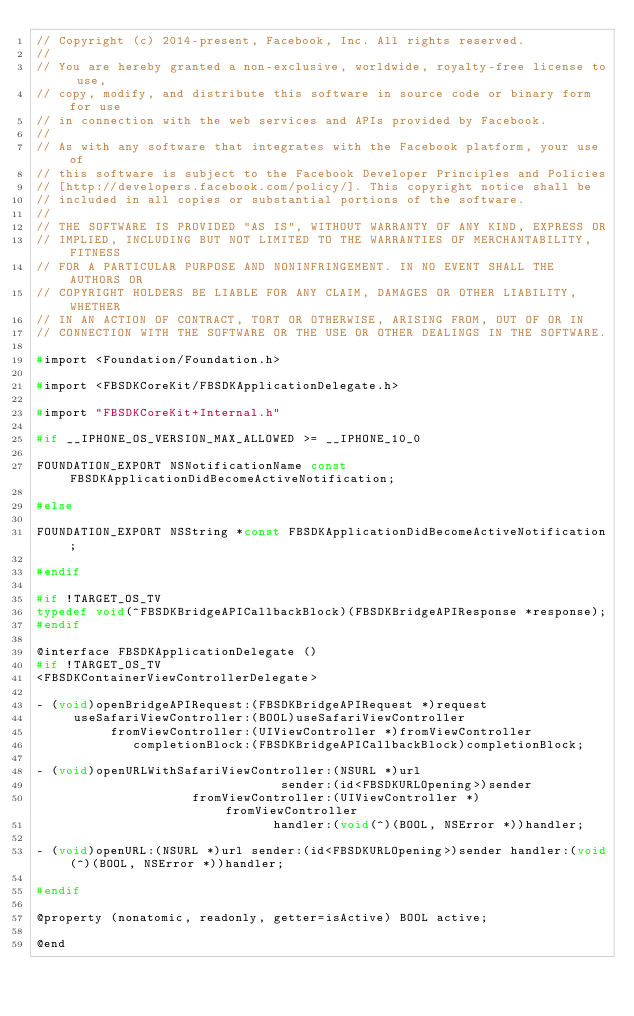Convert code to text. <code><loc_0><loc_0><loc_500><loc_500><_C_>// Copyright (c) 2014-present, Facebook, Inc. All rights reserved.
//
// You are hereby granted a non-exclusive, worldwide, royalty-free license to use,
// copy, modify, and distribute this software in source code or binary form for use
// in connection with the web services and APIs provided by Facebook.
//
// As with any software that integrates with the Facebook platform, your use of
// this software is subject to the Facebook Developer Principles and Policies
// [http://developers.facebook.com/policy/]. This copyright notice shall be
// included in all copies or substantial portions of the software.
//
// THE SOFTWARE IS PROVIDED "AS IS", WITHOUT WARRANTY OF ANY KIND, EXPRESS OR
// IMPLIED, INCLUDING BUT NOT LIMITED TO THE WARRANTIES OF MERCHANTABILITY, FITNESS
// FOR A PARTICULAR PURPOSE AND NONINFRINGEMENT. IN NO EVENT SHALL THE AUTHORS OR
// COPYRIGHT HOLDERS BE LIABLE FOR ANY CLAIM, DAMAGES OR OTHER LIABILITY, WHETHER
// IN AN ACTION OF CONTRACT, TORT OR OTHERWISE, ARISING FROM, OUT OF OR IN
// CONNECTION WITH THE SOFTWARE OR THE USE OR OTHER DEALINGS IN THE SOFTWARE.

#import <Foundation/Foundation.h>

#import <FBSDKCoreKit/FBSDKApplicationDelegate.h>

#import "FBSDKCoreKit+Internal.h"

#if __IPHONE_OS_VERSION_MAX_ALLOWED >= __IPHONE_10_0

FOUNDATION_EXPORT NSNotificationName const FBSDKApplicationDidBecomeActiveNotification;

#else

FOUNDATION_EXPORT NSString *const FBSDKApplicationDidBecomeActiveNotification;

#endif

#if !TARGET_OS_TV
typedef void(^FBSDKBridgeAPICallbackBlock)(FBSDKBridgeAPIResponse *response);
#endif

@interface FBSDKApplicationDelegate ()
#if !TARGET_OS_TV
<FBSDKContainerViewControllerDelegate>

- (void)openBridgeAPIRequest:(FBSDKBridgeAPIRequest *)request
     useSafariViewController:(BOOL)useSafariViewController
          fromViewController:(UIViewController *)fromViewController
             completionBlock:(FBSDKBridgeAPICallbackBlock)completionBlock;

- (void)openURLWithSafariViewController:(NSURL *)url
                                 sender:(id<FBSDKURLOpening>)sender
                     fromViewController:(UIViewController *)fromViewController
                                handler:(void(^)(BOOL, NSError *))handler;

- (void)openURL:(NSURL *)url sender:(id<FBSDKURLOpening>)sender handler:(void(^)(BOOL, NSError *))handler;

#endif

@property (nonatomic, readonly, getter=isActive) BOOL active;

@end
</code> 